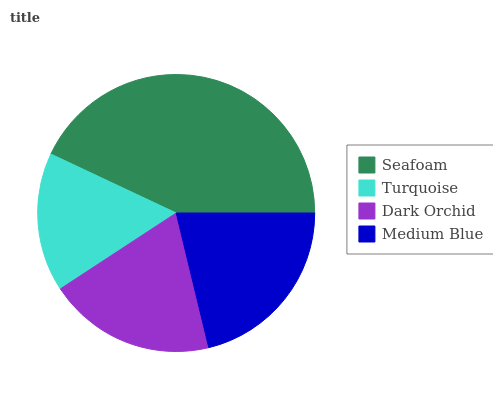Is Turquoise the minimum?
Answer yes or no. Yes. Is Seafoam the maximum?
Answer yes or no. Yes. Is Dark Orchid the minimum?
Answer yes or no. No. Is Dark Orchid the maximum?
Answer yes or no. No. Is Dark Orchid greater than Turquoise?
Answer yes or no. Yes. Is Turquoise less than Dark Orchid?
Answer yes or no. Yes. Is Turquoise greater than Dark Orchid?
Answer yes or no. No. Is Dark Orchid less than Turquoise?
Answer yes or no. No. Is Medium Blue the high median?
Answer yes or no. Yes. Is Dark Orchid the low median?
Answer yes or no. Yes. Is Dark Orchid the high median?
Answer yes or no. No. Is Medium Blue the low median?
Answer yes or no. No. 